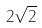Convert formula to latex. <formula><loc_0><loc_0><loc_500><loc_500>2 \sqrt { 2 }</formula> 